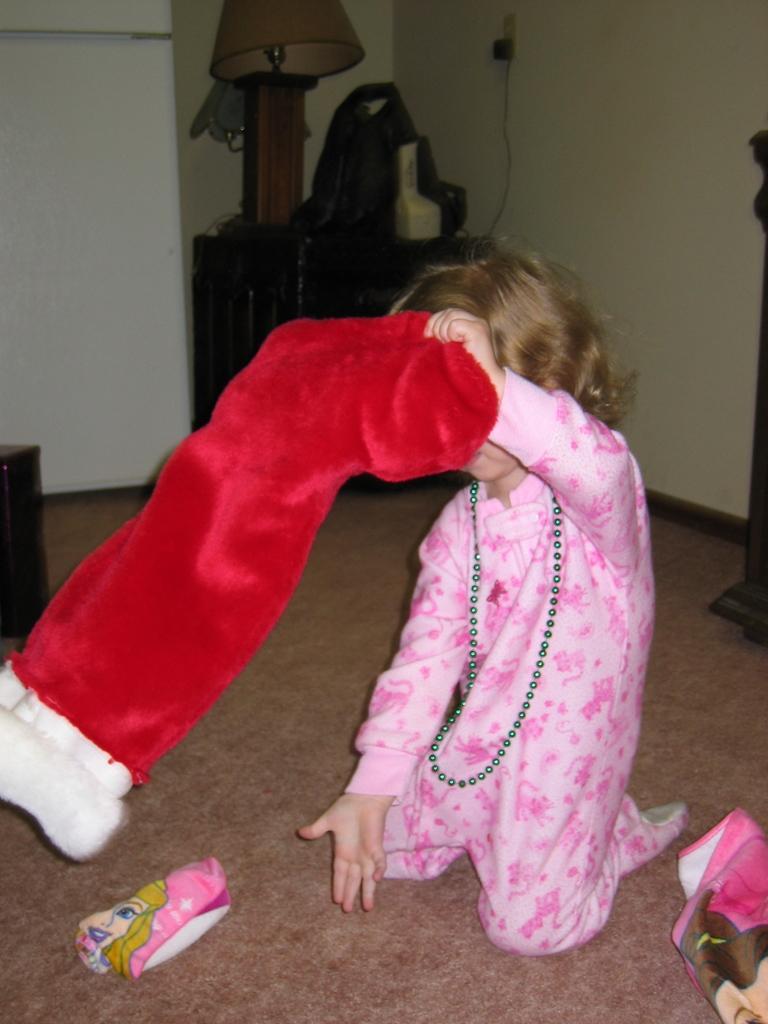Describe this image in one or two sentences. In the middle of the image a girl is sitting and holding a cloth. Behind her there is wall and there is a table, on the table there are some products. At the bottom of the image there are some pouches. 